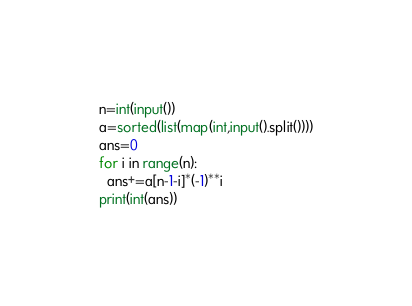Convert code to text. <code><loc_0><loc_0><loc_500><loc_500><_Python_>n=int(input())
a=sorted(list(map(int,input().split())))
ans=0
for i in range(n):
  ans+=a[n-1-i]*(-1)**i
print(int(ans))</code> 